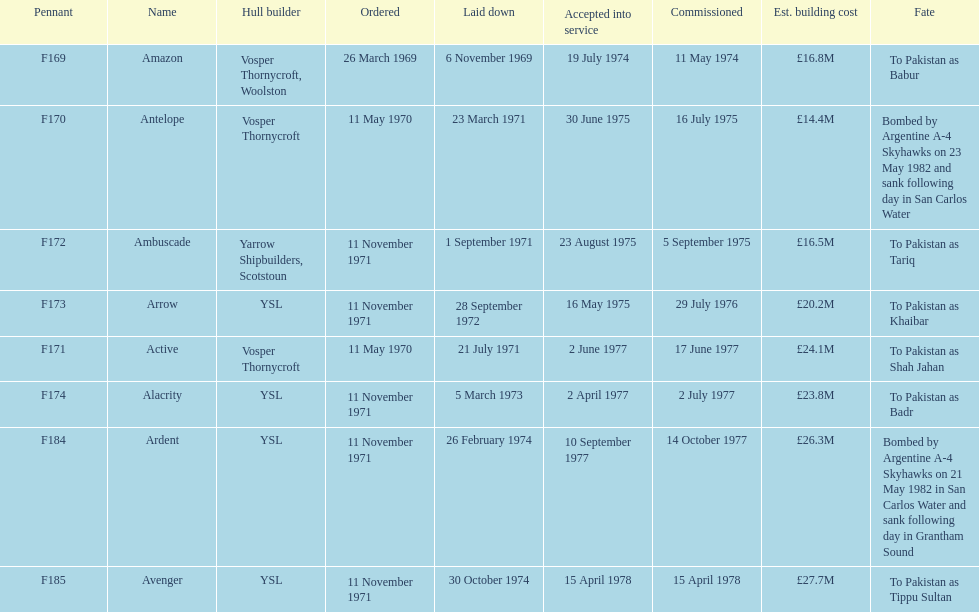Tell me the number of ships that went to pakistan. 6. 